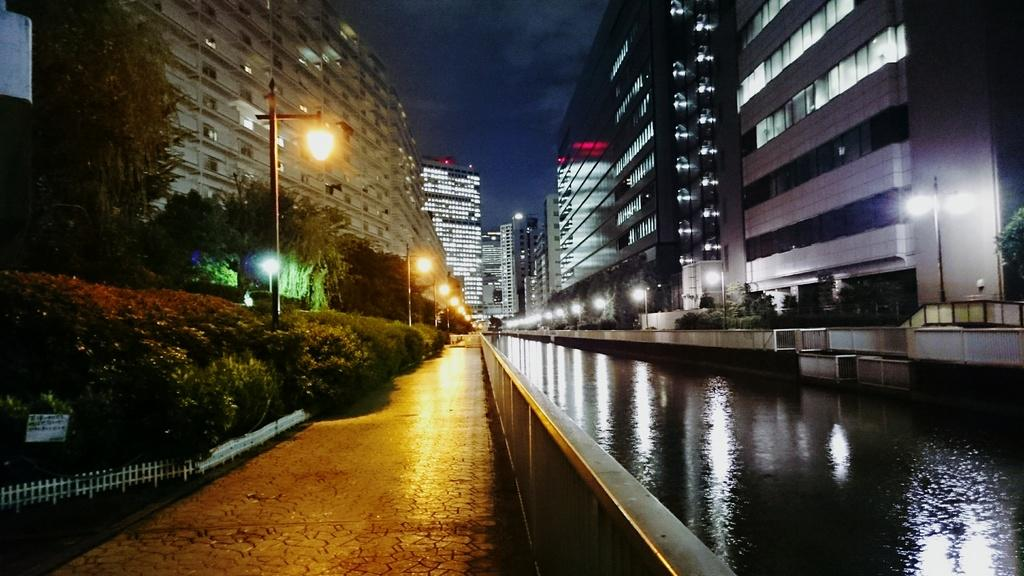What is the primary element in the image? The image contains water. What types of vegetation can be seen in the image? There are plants and trees in the image. What structures are present in the image? There are poles and buildings in the image. What can be seen illuminated in the image? There are lights in the image. What is visible in the background of the image? There are buildings and the sky in the background of the image. What type of potato is being used as a veil in the image? There is no potato or veil present in the image. 